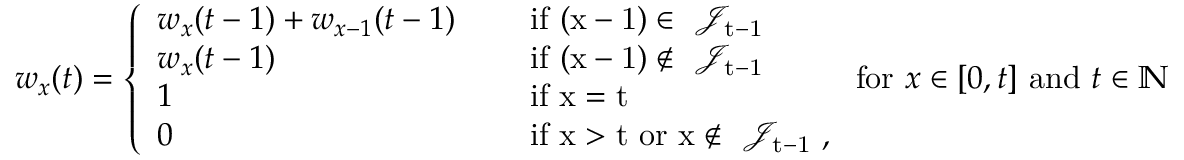Convert formula to latex. <formula><loc_0><loc_0><loc_500><loc_500>w _ { x } ( t ) = \left \{ \begin{array} { l l } { w _ { x } ( t - 1 ) + w _ { x - 1 } ( t - 1 ) \quad } & { i f ( x - 1 ) \in \mathcal { J } _ { t - 1 } } \\ { w _ { x } ( t - 1 ) } & { i f ( x - 1 ) \notin \mathcal { J } _ { t - 1 } } \\ { 1 } & { i f x = t } \\ { 0 } & { i f x > t o r x \notin \mathcal { J } _ { t - 1 } , } \end{array} f o r x \in [ 0 , t ] a n d t \in \mathbb { N }</formula> 